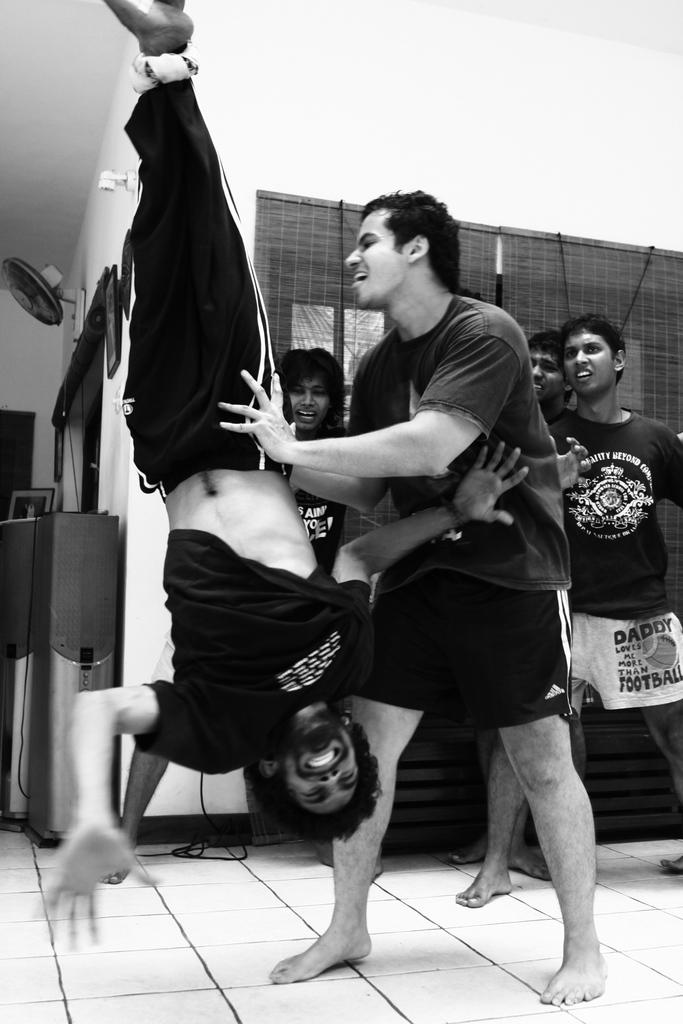How many people are in the image? There are people in the image, but the exact number is not specified. What are the people doing in the image? The people are on the floor, and one person is hanging from a rope. What is the color scheme of the image? The image is black and white. What can be seen in the background of the image? There is a wall in the background of the image. What type of flesh can be seen in the image? There is no flesh visible in the image; it is a black and white image of people on the floor and one person hanging from a rope. How much debt is being discussed in the image? There is no mention of debt or any financial discussions in the image. 